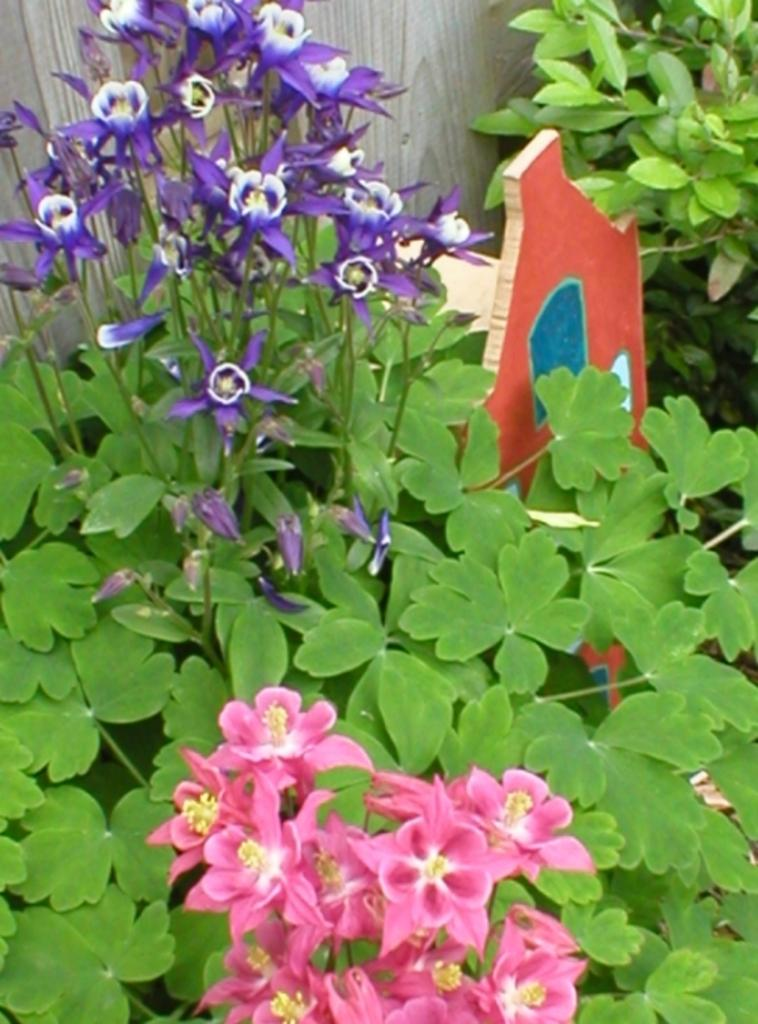What type of living organisms can be seen in the image? Plants can be seen in the image. What distinguishing feature do the plants have? The plants have flowers with different colors. Where are the plants located in the image? The plants are located in the middle of the image. What type of meal is being prepared in the image? There is no meal preparation visible in the image; it features plants with flowers. Can you identify any insects interacting with the plants in the image? There are no insects present in the image; it only shows plants with flowers. 